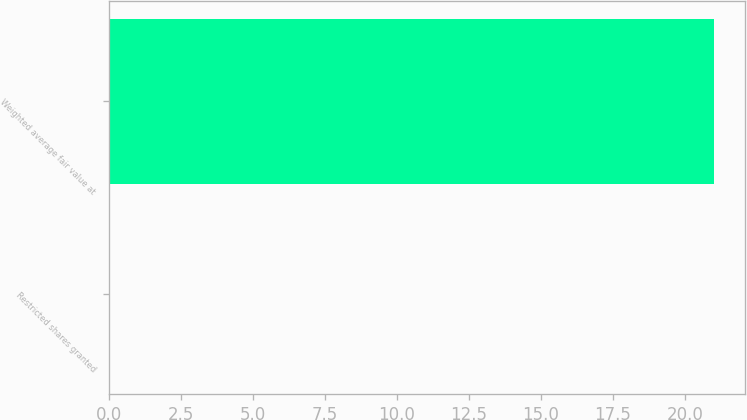Convert chart. <chart><loc_0><loc_0><loc_500><loc_500><bar_chart><fcel>Restricted shares granted<fcel>Weighted average fair value at<nl><fcel>0.03<fcel>21.02<nl></chart> 